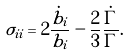<formula> <loc_0><loc_0><loc_500><loc_500>\sigma _ { i i } = 2 \frac { \dot { b } _ { i } } { b _ { i } } - \frac { 2 } { 3 } \frac { \dot { \Gamma } } { \Gamma } .</formula> 